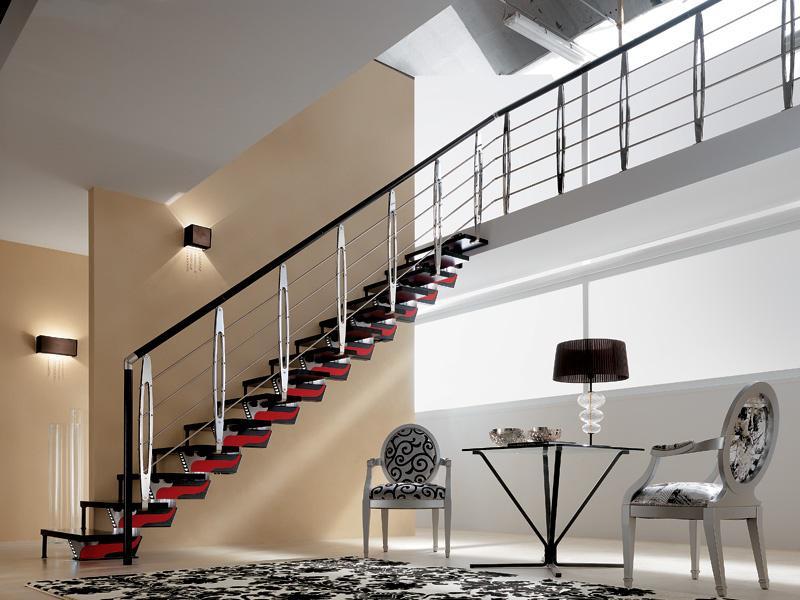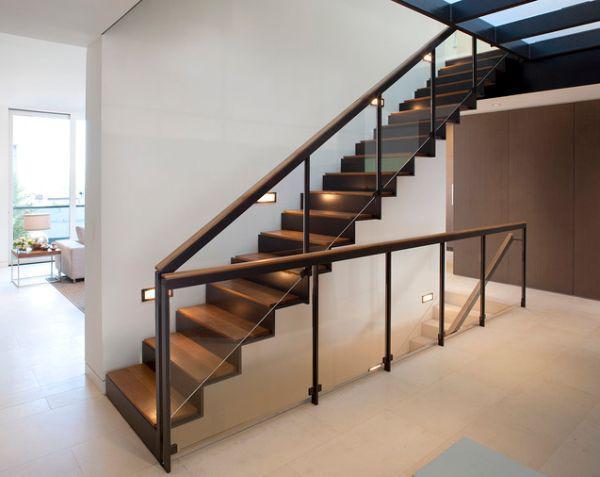The first image is the image on the left, the second image is the image on the right. Analyze the images presented: Is the assertion "One image shows a staircase leading down to the right, with glass panels along the side and flat brown wooden backless steps." valid? Answer yes or no. No. The first image is the image on the left, the second image is the image on the right. Analyze the images presented: Is the assertion "The end of white-faced built-in shelves can be seen in the angled space under a set of stairs in one image." valid? Answer yes or no. No. 